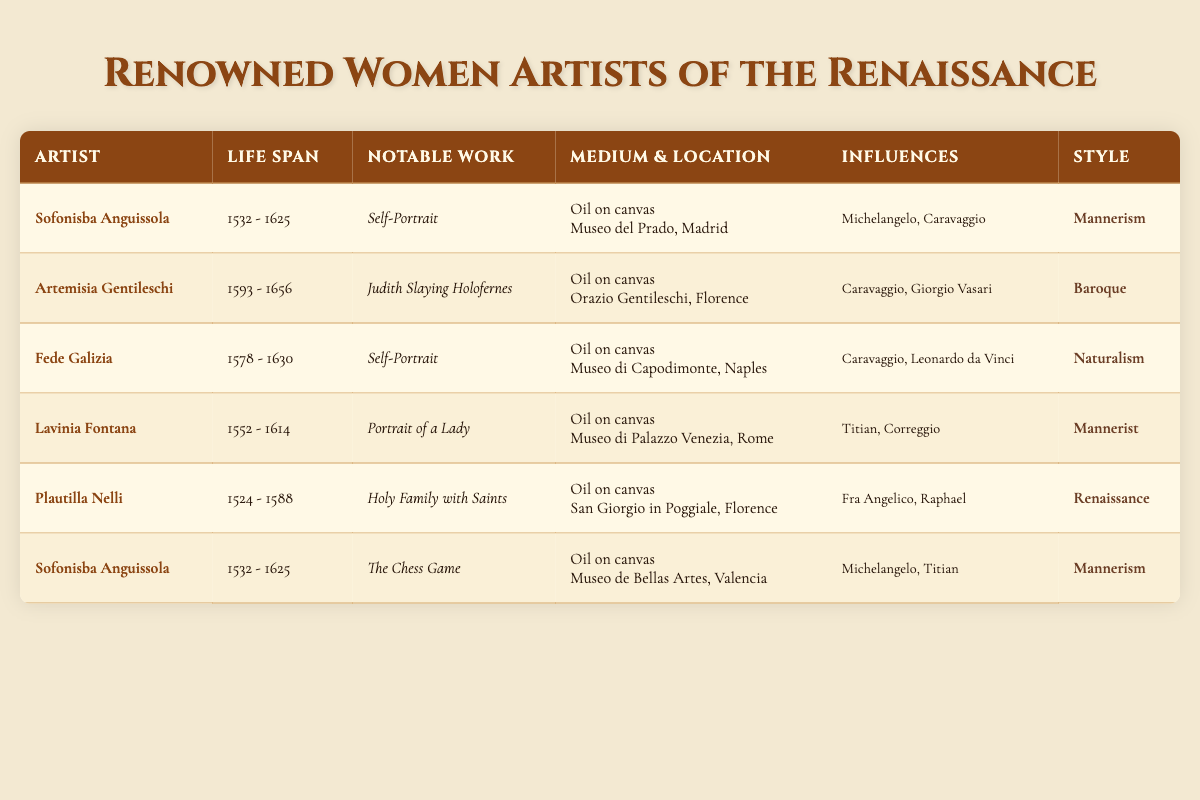What is the birth year of Artemisia Gentileschi? By looking in the table, we can find the row for Artemisia Gentileschi, which shows her birth year as 1593.
Answer: 1593 Which artist has the notable work "Judith Slaying Holofernes"? The table clearly states that the artist associated with "Judith Slaying Holofernes" is Artemisia Gentileschi.
Answer: Artemisia Gentileschi How many artists listed were born before 1550? Scanning the birth years, I see that Plautilla Nelli (1524), Sofonisba Anguissola (1532), and Lavinia Fontana (1552) were all born before 1550, totaling three artists.
Answer: 3 Which artist's works show influences from Caravaggio? Looking at the influences in the table, both Artemisia Gentileschi and Fede Galizia have Caravaggio listed as an influence.
Answer: Artemisia Gentileschi, Fede Galizia What is the difference in birth years between the oldest and youngest artists? The oldest artist is Plautilla Nelli (1524) and the youngest is Artemisia Gentileschi (1593). The difference is 1593 - 1524 = 69 years.
Answer: 69 Are there any artists who created their notable works in the Renaissance style? Yes, according to the table, Plautilla Nelli created "Holy Family with Saints" in the Renaissance style.
Answer: Yes What is the average death year of the artists listed? Considering the death years: 1625, 1656, 1630, 1614, 1588, and 1625, we sum them up: (1625 + 1656 + 1630 + 1614 + 1588 + 1625) = 7938. There are 6 artists, so the average death year is 7938 / 6 = 1315.
Answer: 1315 Which artist created two notable works listed in the table? By examining the table, I see that Sofonisba Anguissola is mentioned twice for her works "Self-Portrait" and "The Chess Game."
Answer: Sofonisba Anguissola In which medium did Lavinia Fontana create her notable work? The table states that Lavinia Fontana's "Portrait of a Lady" was created using oil on canvas.
Answer: Oil on canvas What styles are represented by Fede Galizia and Lavinia Fontana? Fede Galizia is noted as a Naturalist, while Lavinia Fontana is classified under Mannerist style in the table.
Answer: Naturalism and Mannerist 